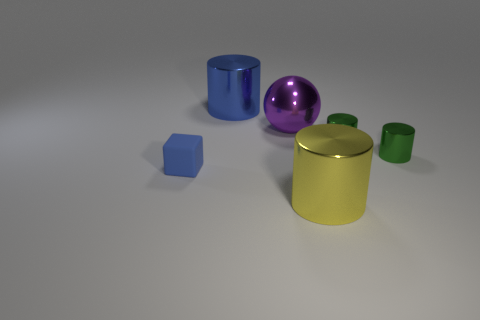How many balls are metallic things or big cyan matte objects? In the scene, there is one spherical object that appears to be metallic due to its reflective surface. As for big cyan matte objects, there is one large cyan cube present. Therefore, there is one object that is both a ball and metallic, and one object that is a big cyan matte, but it is not a ball. 